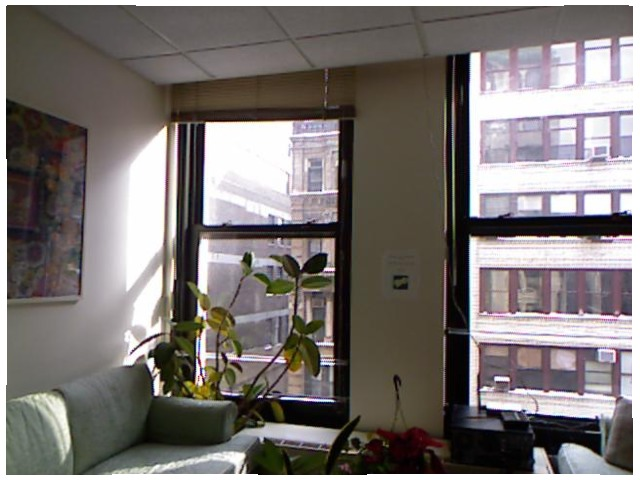<image>
Is there a plant in front of the sofa? No. The plant is not in front of the sofa. The spatial positioning shows a different relationship between these objects. Is there a photo next to the window? Yes. The photo is positioned adjacent to the window, located nearby in the same general area. Is there a plant above the table? Yes. The plant is positioned above the table in the vertical space, higher up in the scene. Where is the window in relation to the flower? Is it in the flower? No. The window is not contained within the flower. These objects have a different spatial relationship. 